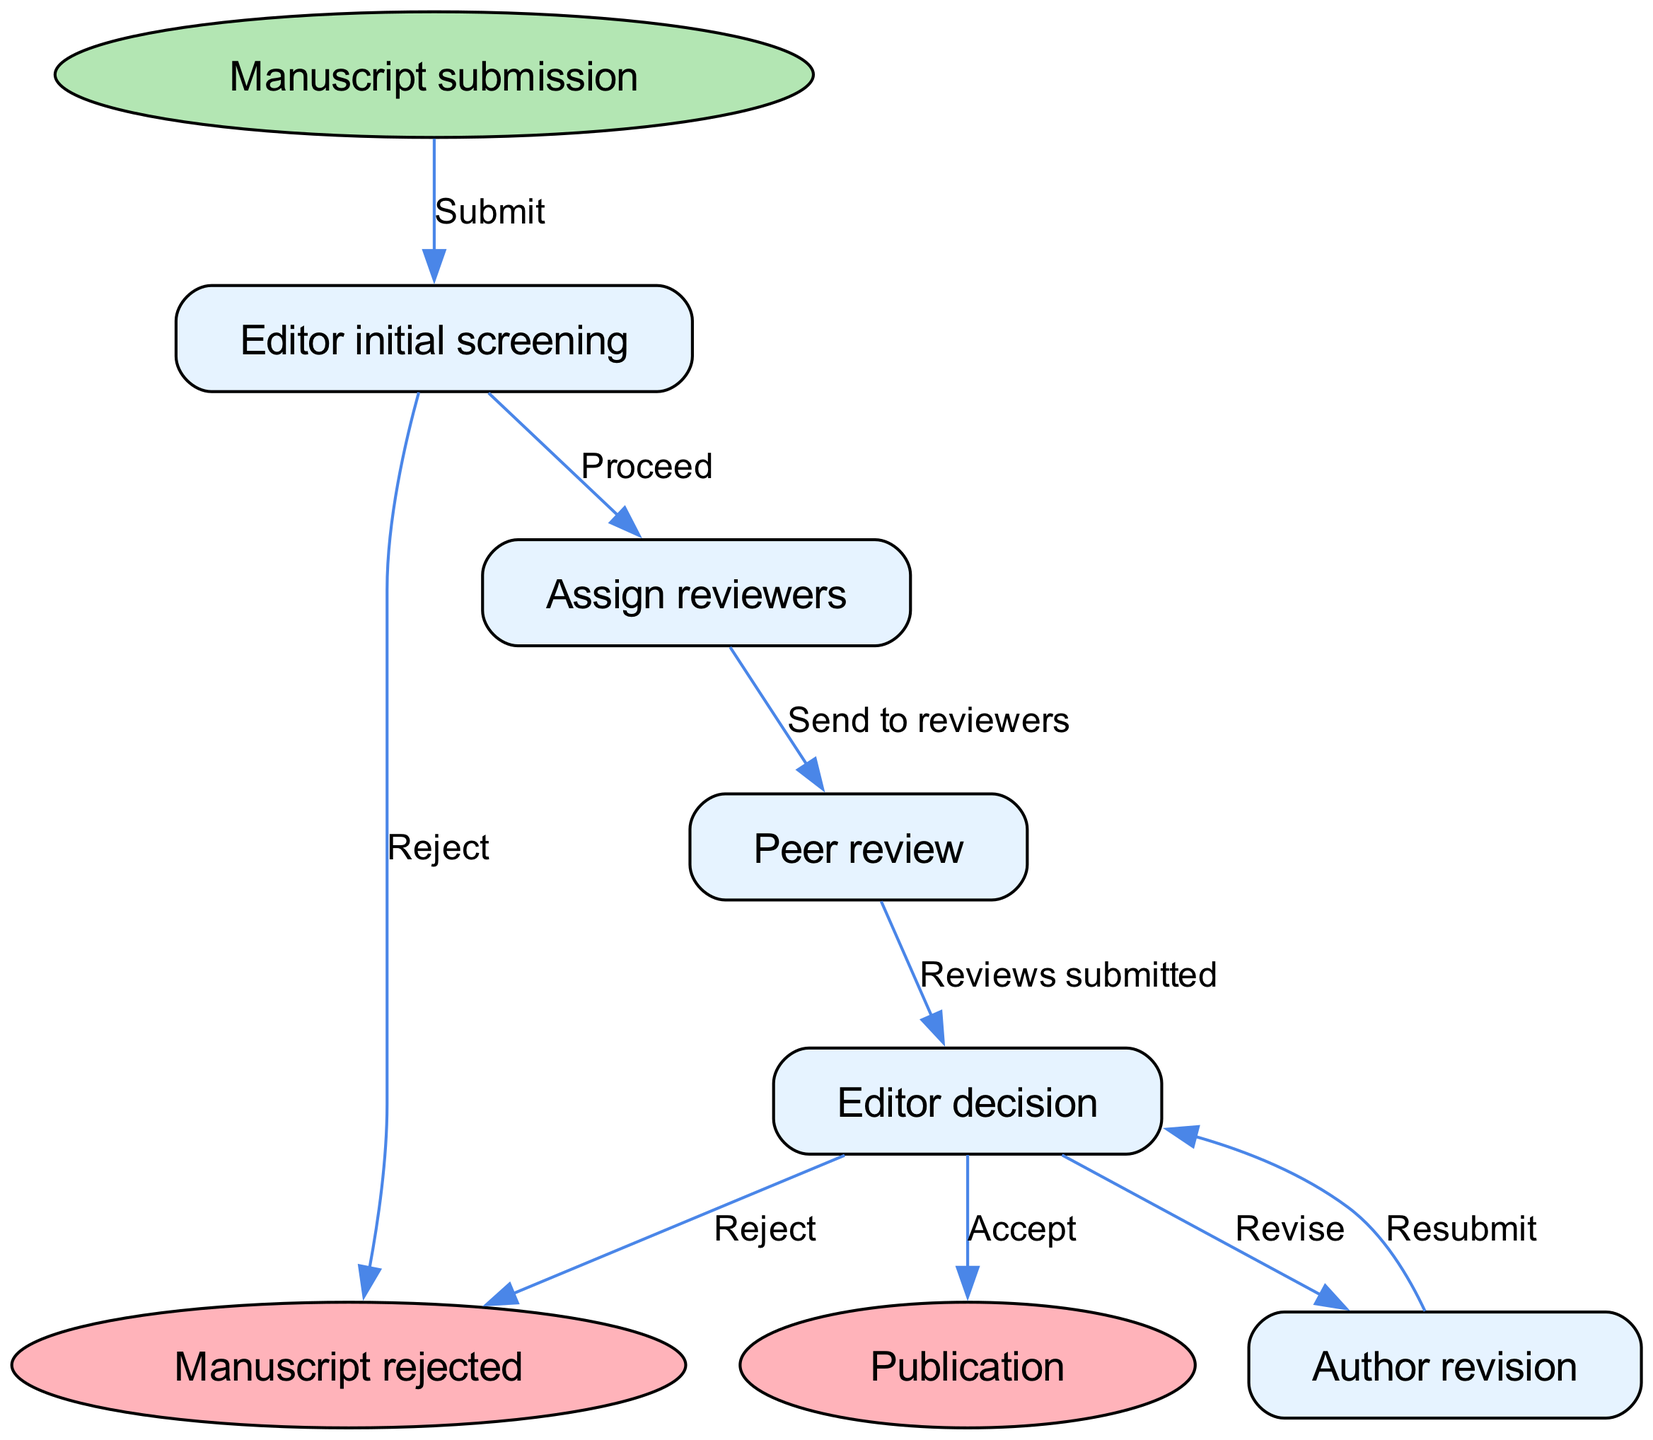What is the starting point of the flow chart? The flow chart starts with the node labeled "Manuscript submission", which is indicated as the entry point.
Answer: Manuscript submission How many main process nodes are there in the diagram? The diagram includes five main process nodes: "Editor initial screening", "Assign reviewers", "Peer review", "Editor decision", and "Author revision". Therefore, the total is five.
Answer: 5 What happens if the editor decides to reject the manuscript? If the editor rejects the manuscript during the "Editor decision" node, it flows directly to the "Manuscript rejected" endpoint.
Answer: Manuscript rejected What is the outcome if the manuscript is accepted? If the manuscript is accepted during the "Editor decision" node, it leads to the "Publication" endpoint, indicating the manuscript will be published.
Answer: Publication What is the next step after "Author revision"? After the authors revise their manuscript, the next step is to "Resubmit" it, which brings them back to the "Editor decision" node for evaluation again.
Answer: Editor decision What are the possible outcomes after the peer review is completed? Once the peer review is completed and the reviews are submitted, the next step is the "Editor decision", where the outcomes can be accept, revise, or reject.
Answer: Accept, Revise, Reject How many edges connect to the "Editor decision" node? The "Editor decision" node has three outgoing edges: one for "Accept", one for "Revise", and one for "Reject".
Answer: 3 What is the relationship between "Editor initial screening" and "Assign reviewers"? If the initial screening by the editor is successful and the manuscript does not get rejected, it proceeds to the "Assign reviewers" node, indicating a conditional flow from one to the other.
Answer: Proceed What is the end point of the process after a successful publication? The endpoint indicating a successful outcome after the editor's acceptance decision is "Publication".
Answer: Publication 